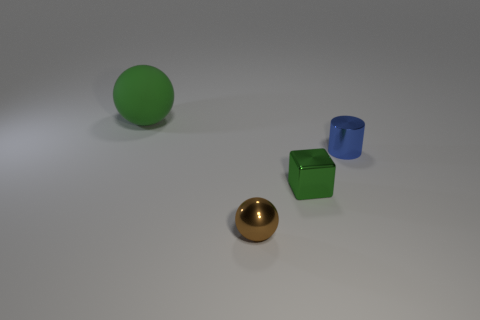There is a object that is on the left side of the block and behind the tiny ball; what shape is it?
Your answer should be compact. Sphere. Are there the same number of brown objects that are to the left of the small brown thing and large green cylinders?
Your response must be concise. Yes. How many objects are large metal cubes or small objects to the right of the brown metallic ball?
Keep it short and to the point. 2. Is there a yellow metallic object of the same shape as the large green rubber object?
Provide a succinct answer. No. Are there the same number of brown shiny objects in front of the small green metallic thing and tiny cylinders that are in front of the tiny shiny ball?
Ensure brevity in your answer.  No. Are there any other things that are the same size as the green sphere?
Give a very brief answer. No. What number of purple objects are either metallic cylinders or tiny shiny spheres?
Offer a terse response. 0. What number of metallic objects have the same size as the metal ball?
Give a very brief answer. 2. What color is the thing that is both to the right of the metal sphere and behind the tiny metallic cube?
Your answer should be compact. Blue. Is the number of small things left of the tiny green metallic block greater than the number of small gray balls?
Keep it short and to the point. Yes. 